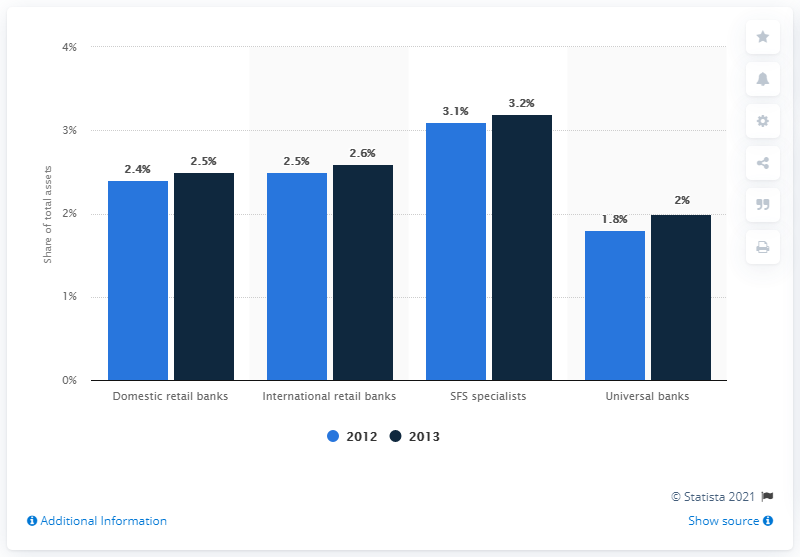Draw attention to some important aspects in this diagram. In 2013, domestic retail banks accounted for approximately 2.5% of total assets of the banking industry. 